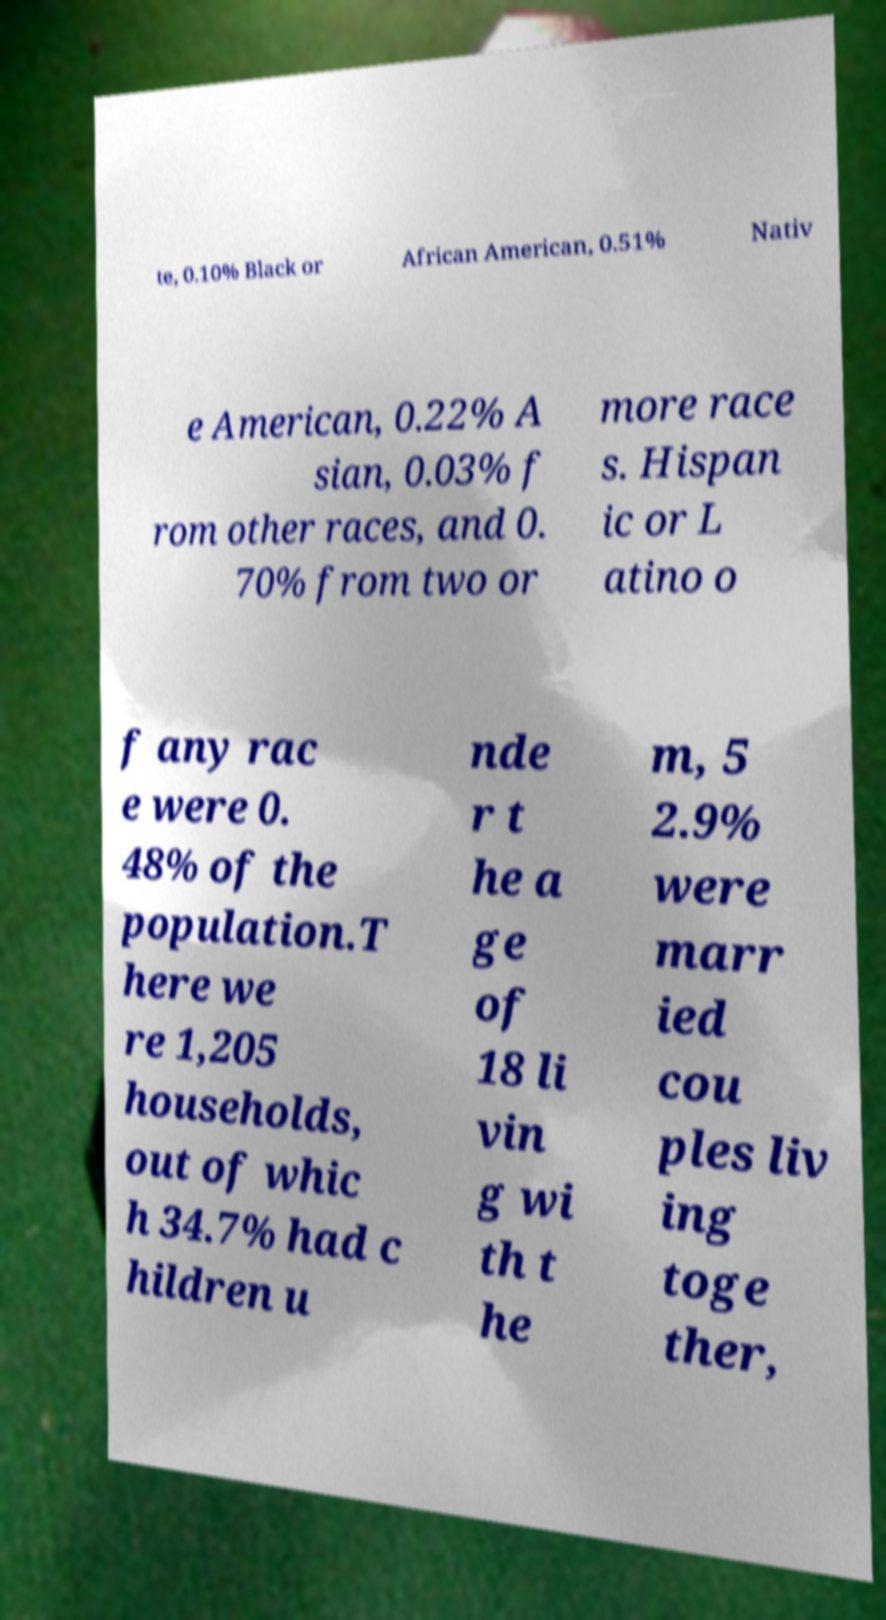What messages or text are displayed in this image? I need them in a readable, typed format. te, 0.10% Black or African American, 0.51% Nativ e American, 0.22% A sian, 0.03% f rom other races, and 0. 70% from two or more race s. Hispan ic or L atino o f any rac e were 0. 48% of the population.T here we re 1,205 households, out of whic h 34.7% had c hildren u nde r t he a ge of 18 li vin g wi th t he m, 5 2.9% were marr ied cou ples liv ing toge ther, 